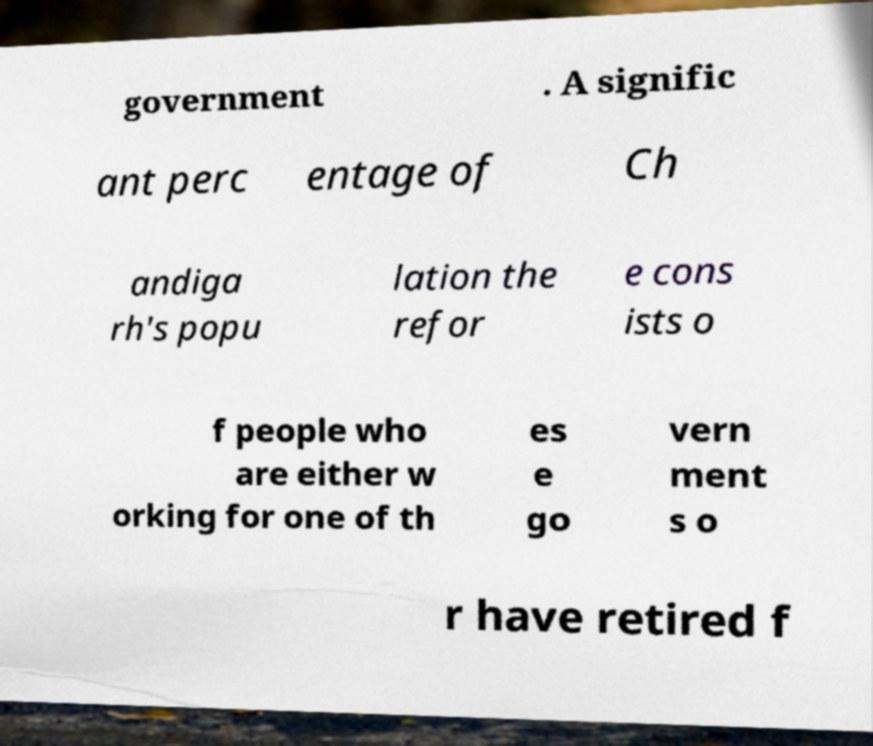Can you read and provide the text displayed in the image?This photo seems to have some interesting text. Can you extract and type it out for me? government . A signific ant perc entage of Ch andiga rh's popu lation the refor e cons ists o f people who are either w orking for one of th es e go vern ment s o r have retired f 